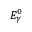Convert formula to latex. <formula><loc_0><loc_0><loc_500><loc_500>E _ { \gamma } ^ { 0 }</formula> 